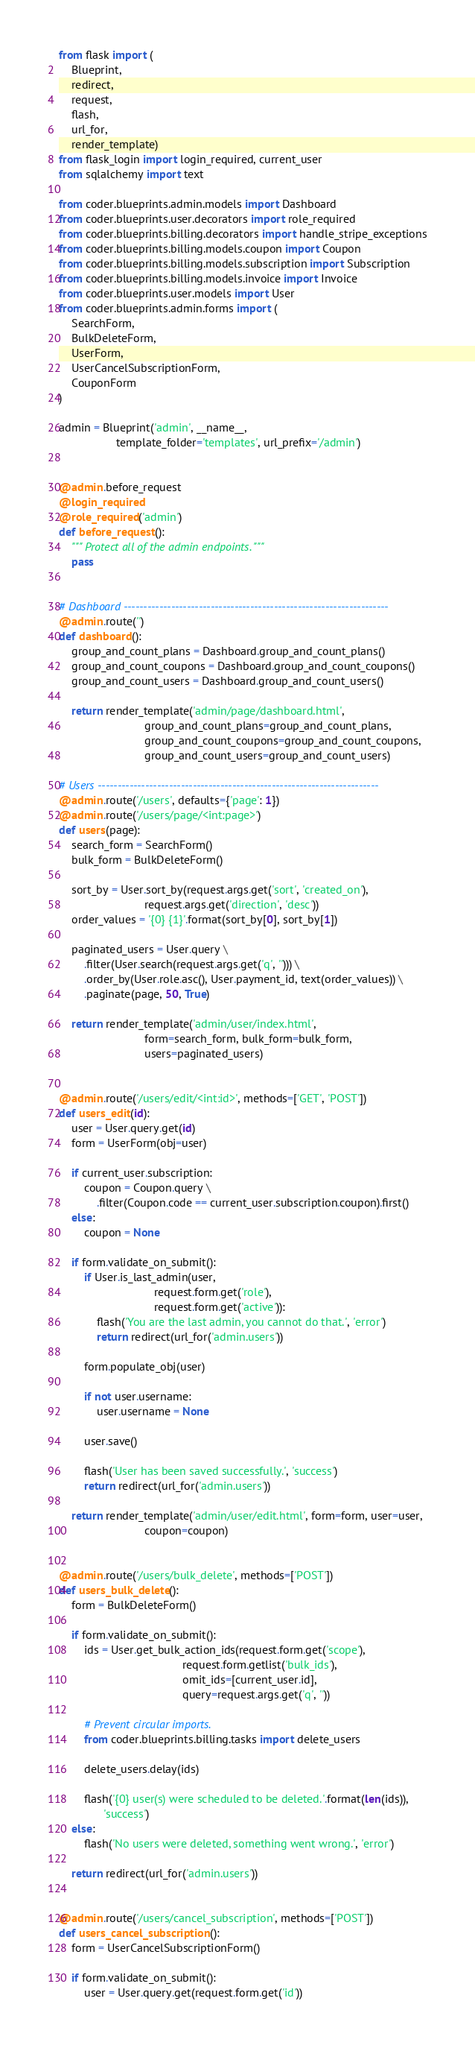Convert code to text. <code><loc_0><loc_0><loc_500><loc_500><_Python_>from flask import (
    Blueprint,
    redirect,
    request,
    flash,
    url_for,
    render_template)
from flask_login import login_required, current_user
from sqlalchemy import text

from coder.blueprints.admin.models import Dashboard
from coder.blueprints.user.decorators import role_required
from coder.blueprints.billing.decorators import handle_stripe_exceptions
from coder.blueprints.billing.models.coupon import Coupon
from coder.blueprints.billing.models.subscription import Subscription
from coder.blueprints.billing.models.invoice import Invoice
from coder.blueprints.user.models import User
from coder.blueprints.admin.forms import (
    SearchForm,
    BulkDeleteForm,
    UserForm,
    UserCancelSubscriptionForm,
    CouponForm
)

admin = Blueprint('admin', __name__,
                  template_folder='templates', url_prefix='/admin')


@admin.before_request
@login_required
@role_required('admin')
def before_request():
    """ Protect all of the admin endpoints. """
    pass


# Dashboard -------------------------------------------------------------------
@admin.route('')
def dashboard():
    group_and_count_plans = Dashboard.group_and_count_plans()
    group_and_count_coupons = Dashboard.group_and_count_coupons()
    group_and_count_users = Dashboard.group_and_count_users()

    return render_template('admin/page/dashboard.html',
                           group_and_count_plans=group_and_count_plans,
                           group_and_count_coupons=group_and_count_coupons,
                           group_and_count_users=group_and_count_users)

# Users -----------------------------------------------------------------------
@admin.route('/users', defaults={'page': 1})
@admin.route('/users/page/<int:page>')
def users(page):
    search_form = SearchForm()
    bulk_form = BulkDeleteForm()

    sort_by = User.sort_by(request.args.get('sort', 'created_on'),
                           request.args.get('direction', 'desc'))
    order_values = '{0} {1}'.format(sort_by[0], sort_by[1])

    paginated_users = User.query \
        .filter(User.search(request.args.get('q', ''))) \
        .order_by(User.role.asc(), User.payment_id, text(order_values)) \
        .paginate(page, 50, True)

    return render_template('admin/user/index.html',
                           form=search_form, bulk_form=bulk_form,
                           users=paginated_users)


@admin.route('/users/edit/<int:id>', methods=['GET', 'POST'])
def users_edit(id):
    user = User.query.get(id)
    form = UserForm(obj=user)

    if current_user.subscription:
        coupon = Coupon.query \
            .filter(Coupon.code == current_user.subscription.coupon).first()
    else:
        coupon = None

    if form.validate_on_submit():
        if User.is_last_admin(user,
                              request.form.get('role'),
                              request.form.get('active')):
            flash('You are the last admin, you cannot do that.', 'error')
            return redirect(url_for('admin.users'))

        form.populate_obj(user)

        if not user.username:
            user.username = None

        user.save()

        flash('User has been saved successfully.', 'success')
        return redirect(url_for('admin.users'))

    return render_template('admin/user/edit.html', form=form, user=user,
                           coupon=coupon)


@admin.route('/users/bulk_delete', methods=['POST'])
def users_bulk_delete():
    form = BulkDeleteForm()

    if form.validate_on_submit():
        ids = User.get_bulk_action_ids(request.form.get('scope'),
                                       request.form.getlist('bulk_ids'),
                                       omit_ids=[current_user.id],
                                       query=request.args.get('q', ''))

        # Prevent circular imports.
        from coder.blueprints.billing.tasks import delete_users

        delete_users.delay(ids)

        flash('{0} user(s) were scheduled to be deleted.'.format(len(ids)),
              'success')
    else:
        flash('No users were deleted, something went wrong.', 'error')

    return redirect(url_for('admin.users'))


@admin.route('/users/cancel_subscription', methods=['POST'])
def users_cancel_subscription():
    form = UserCancelSubscriptionForm()

    if form.validate_on_submit():
        user = User.query.get(request.form.get('id'))
</code> 